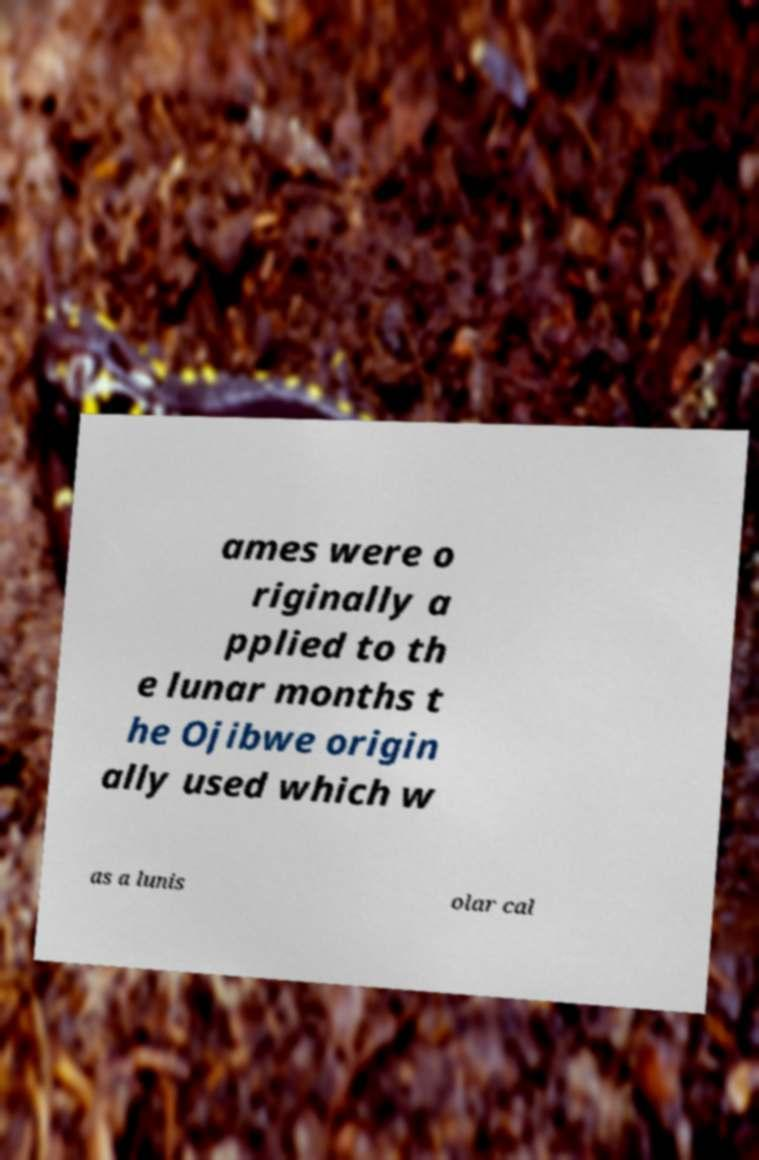Can you accurately transcribe the text from the provided image for me? ames were o riginally a pplied to th e lunar months t he Ojibwe origin ally used which w as a lunis olar cal 